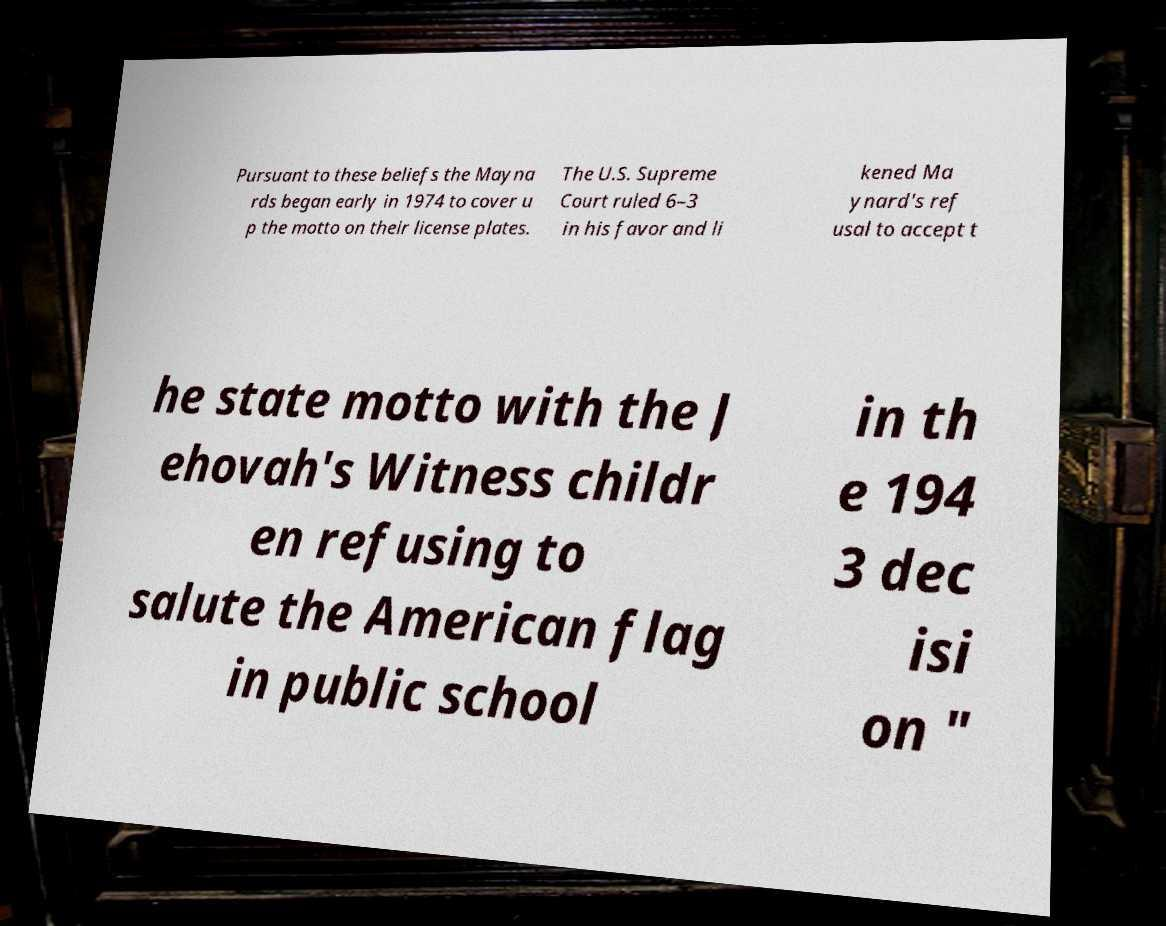Can you read and provide the text displayed in the image?This photo seems to have some interesting text. Can you extract and type it out for me? Pursuant to these beliefs the Mayna rds began early in 1974 to cover u p the motto on their license plates. The U.S. Supreme Court ruled 6–3 in his favor and li kened Ma ynard's ref usal to accept t he state motto with the J ehovah's Witness childr en refusing to salute the American flag in public school in th e 194 3 dec isi on " 